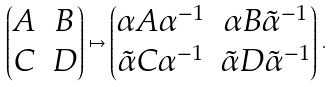Convert formula to latex. <formula><loc_0><loc_0><loc_500><loc_500>\begin{pmatrix} A & B \\ C & D \end{pmatrix} \mapsto \begin{pmatrix} \alpha A \alpha ^ { - 1 } & \alpha B \tilde { \alpha } ^ { - 1 } \\ \tilde { \alpha } C \alpha ^ { - 1 } & \tilde { \alpha } D \tilde { \alpha } ^ { - 1 } \end{pmatrix} \, .</formula> 